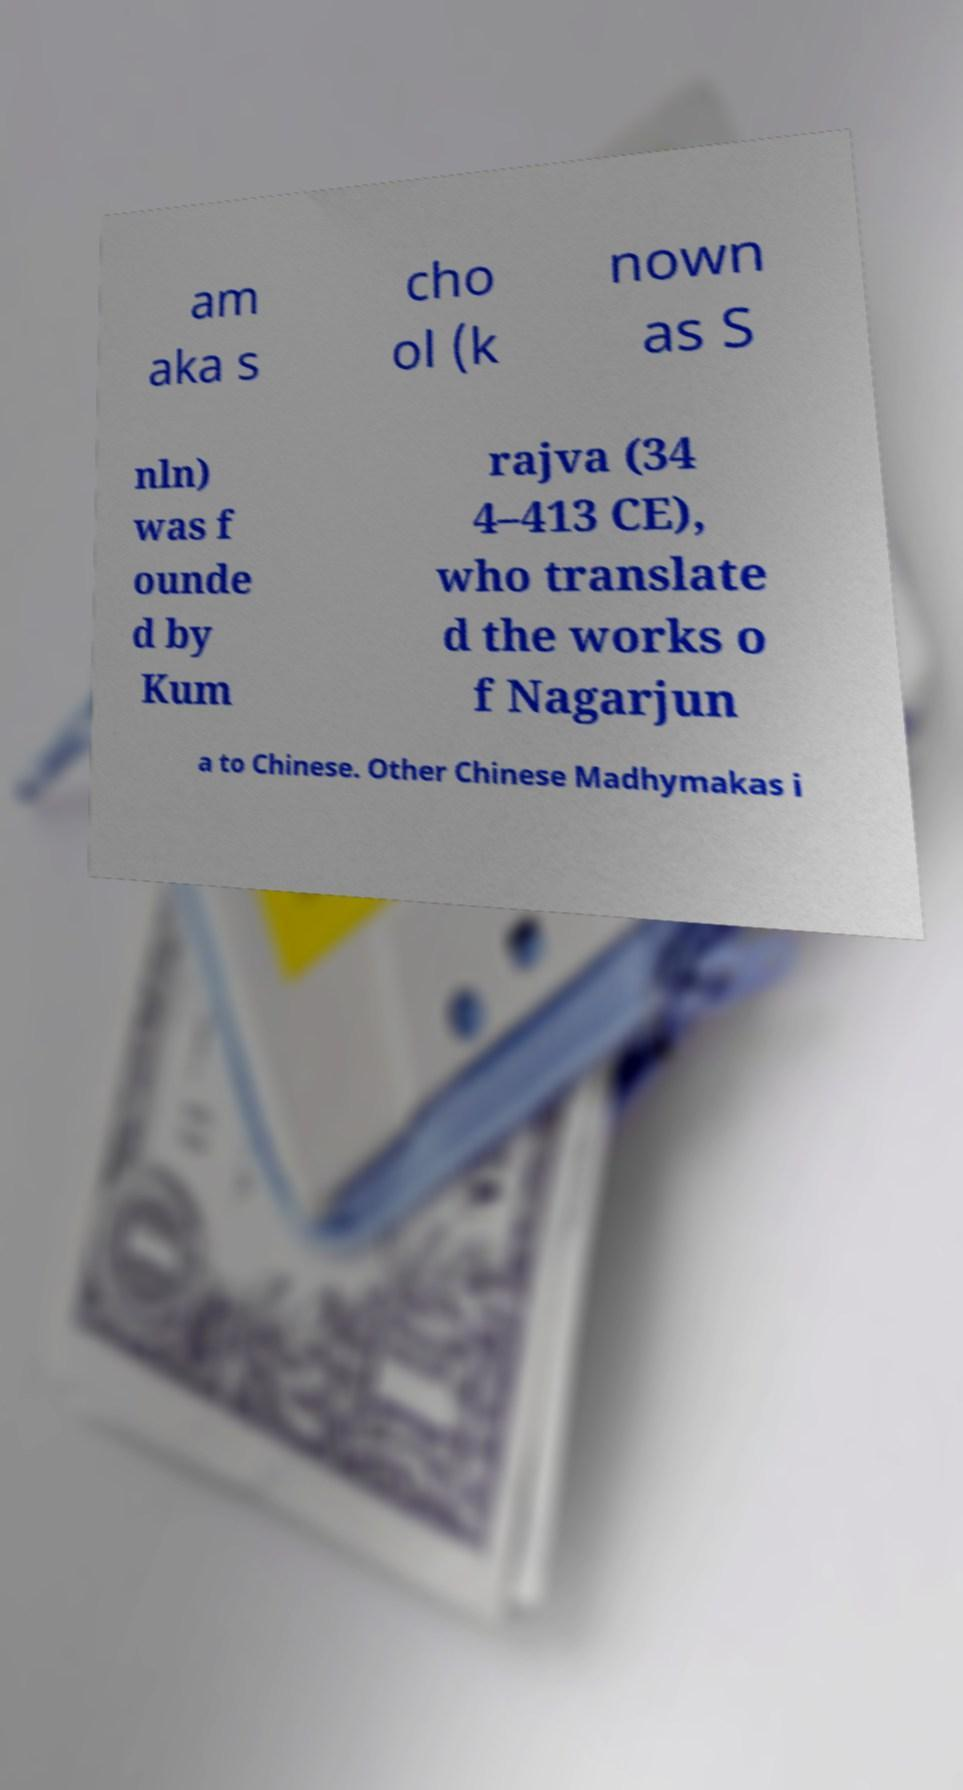Please read and relay the text visible in this image. What does it say? am aka s cho ol (k nown as S nln) was f ounde d by Kum rajva (34 4–413 CE), who translate d the works o f Nagarjun a to Chinese. Other Chinese Madhymakas i 